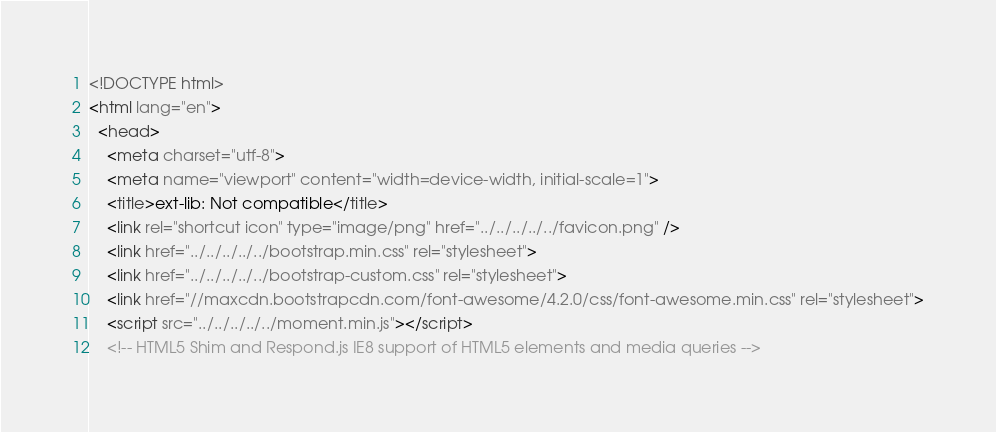<code> <loc_0><loc_0><loc_500><loc_500><_HTML_><!DOCTYPE html>
<html lang="en">
  <head>
    <meta charset="utf-8">
    <meta name="viewport" content="width=device-width, initial-scale=1">
    <title>ext-lib: Not compatible</title>
    <link rel="shortcut icon" type="image/png" href="../../../../../favicon.png" />
    <link href="../../../../../bootstrap.min.css" rel="stylesheet">
    <link href="../../../../../bootstrap-custom.css" rel="stylesheet">
    <link href="//maxcdn.bootstrapcdn.com/font-awesome/4.2.0/css/font-awesome.min.css" rel="stylesheet">
    <script src="../../../../../moment.min.js"></script>
    <!-- HTML5 Shim and Respond.js IE8 support of HTML5 elements and media queries --></code> 